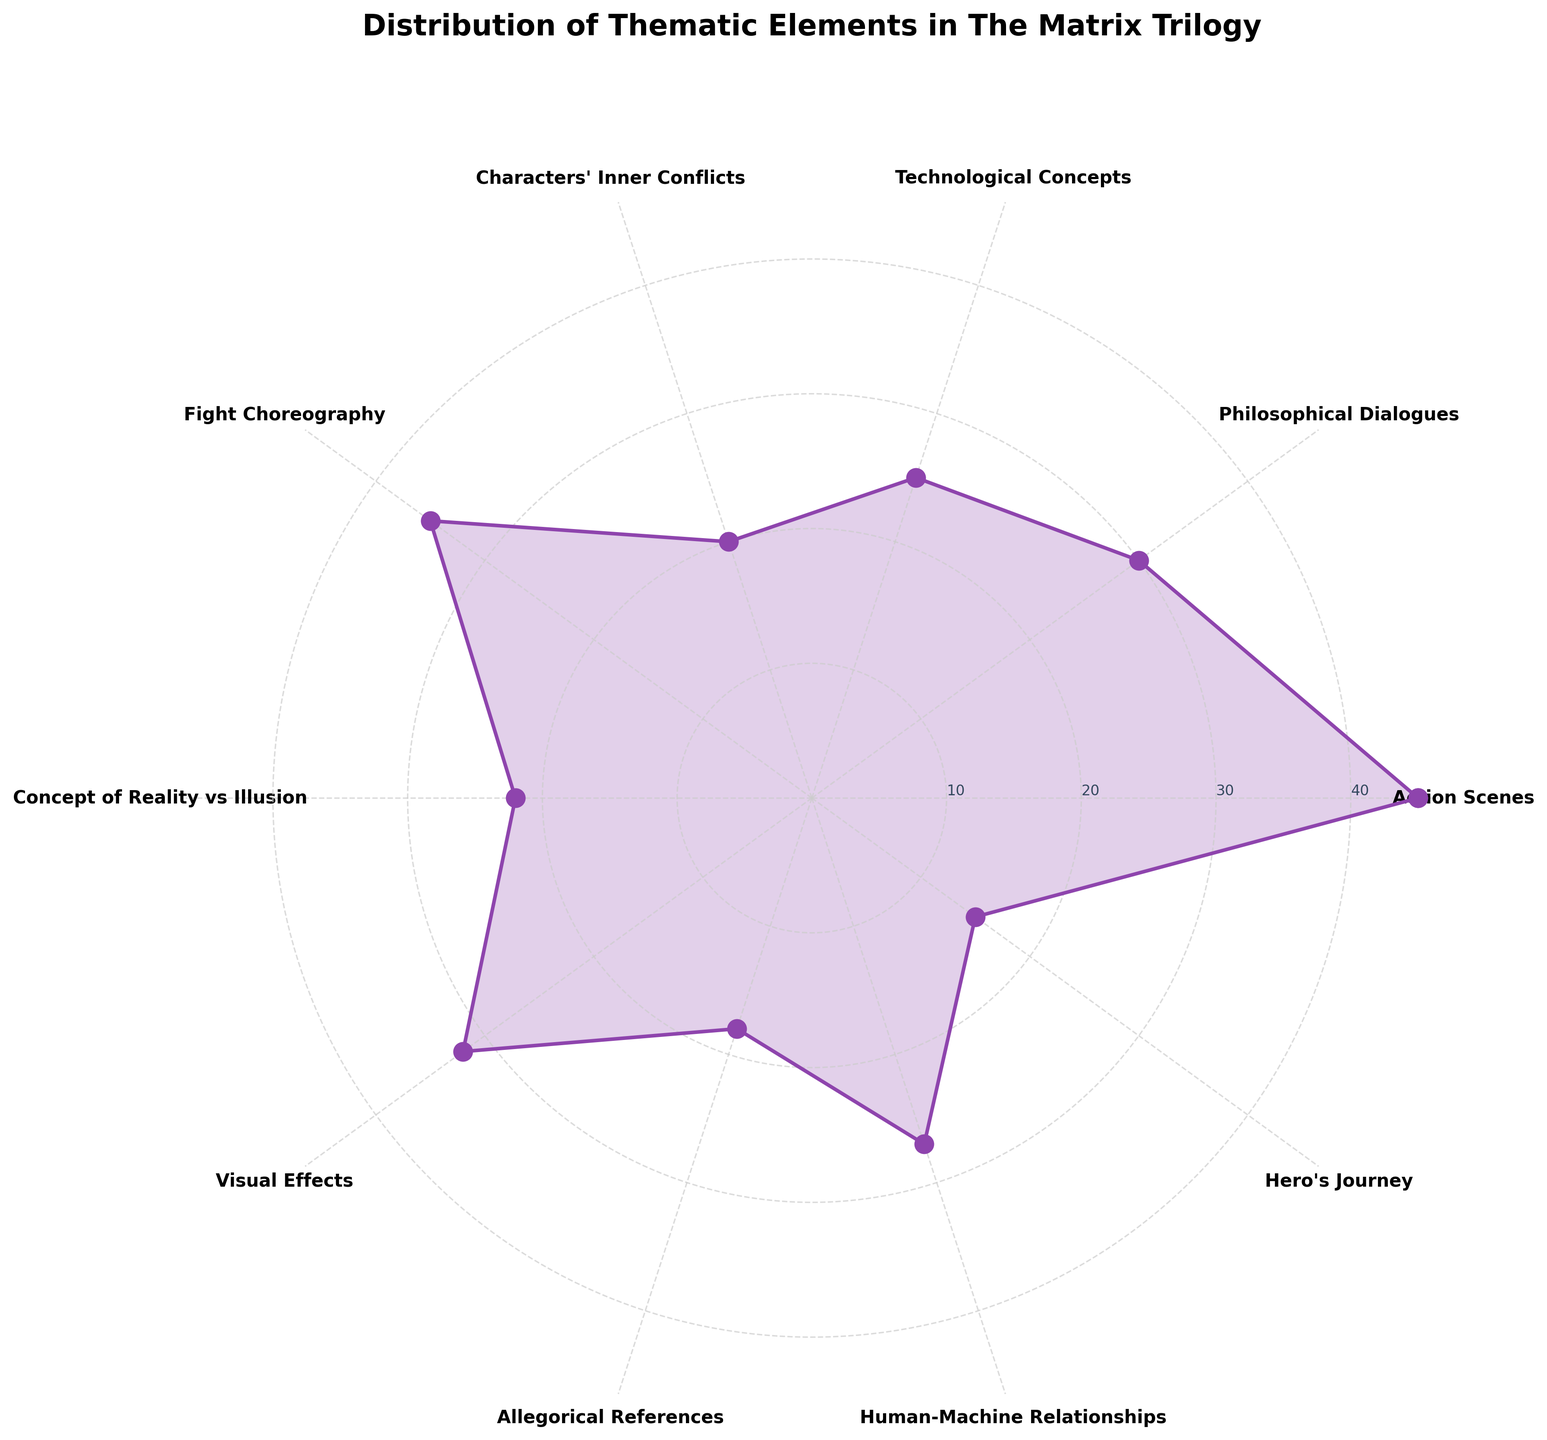Which thematic element has the highest frequency? The thematic element 'Action Scenes' has the highest frequency since it extends the furthest on the rose chart.
Answer: Action Scenes What thematic element is represented by the shortest section? The section representing 'Hero's Journey' is the shortest, indicating it has the lowest frequency.
Answer: Hero's Journey How do the frequencies of 'Philosophical Dialogues' and 'Technological Concepts' compare? By comparing their lengths, 'Philosophical Dialogues' have a higher frequency than 'Technological Concepts.'
Answer: Philosophical Dialogues What is the combined frequency of 'Characters' Inner Conflicts' and 'Human-Machine Relationships'? Add the frequencies for 'Characters' Inner Conflicts' (20) and 'Human-Machine Relationships' (27) resulting in a sum of 47.
Answer: 47 Which thematic element has a frequency closest to the average frequency? First, compute the average frequency: (45 + 30 + 25 + 20 + 35 + 22 + 32 + 18 + 27 + 15) / 10 = 26.9. 'Technological Concepts' with a frequency of 25 is closest to this average.
Answer: Technological Concepts How many thematic elements have frequencies above 30? Thematic elements 'Action Scenes' (45), 'Fight Choreography' (35), and 'Visual Effects' (32) have frequencies above 30.
Answer: 3 Which thematic elements have frequencies below 20? By checking the chart, 'Allegorical References' (18) and 'Hero's Journey' (15) have frequencies below 20.
Answer: Allegorical References, Hero's Journey In what order do the frequencies of 'Fight Choreography', 'Visual Effects', and 'Allegorical References' rank? 'Fight Choreography' has the highest frequency (35), followed by 'Visual Effects' (32) and 'Allegorical References' (18).
Answer: Fight Choreography, Visual Effects, Allegorical References What is the frequency difference between 'Action Scenes' and 'Hero's Journey'? Subtract the frequency of 'Hero's Journey' (15) from 'Action Scenes' (45), resulting in a difference of 30.
Answer: 30 